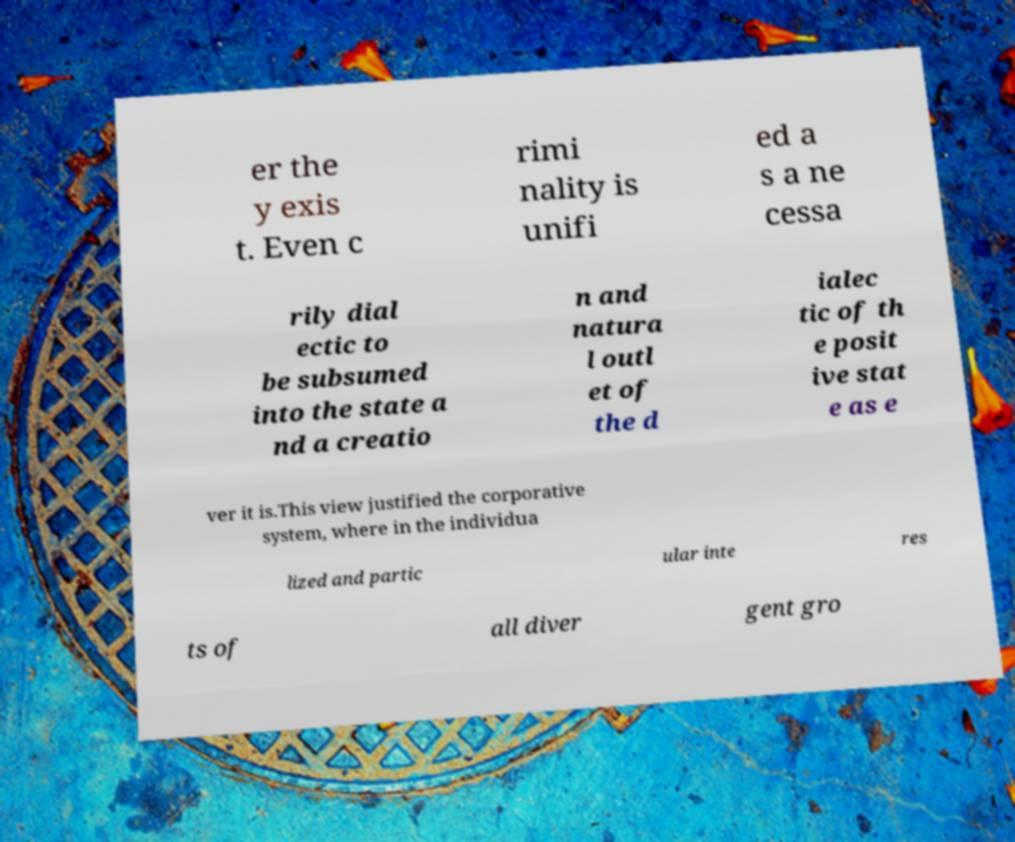What messages or text are displayed in this image? I need them in a readable, typed format. er the y exis t. Even c rimi nality is unifi ed a s a ne cessa rily dial ectic to be subsumed into the state a nd a creatio n and natura l outl et of the d ialec tic of th e posit ive stat e as e ver it is.This view justified the corporative system, where in the individua lized and partic ular inte res ts of all diver gent gro 